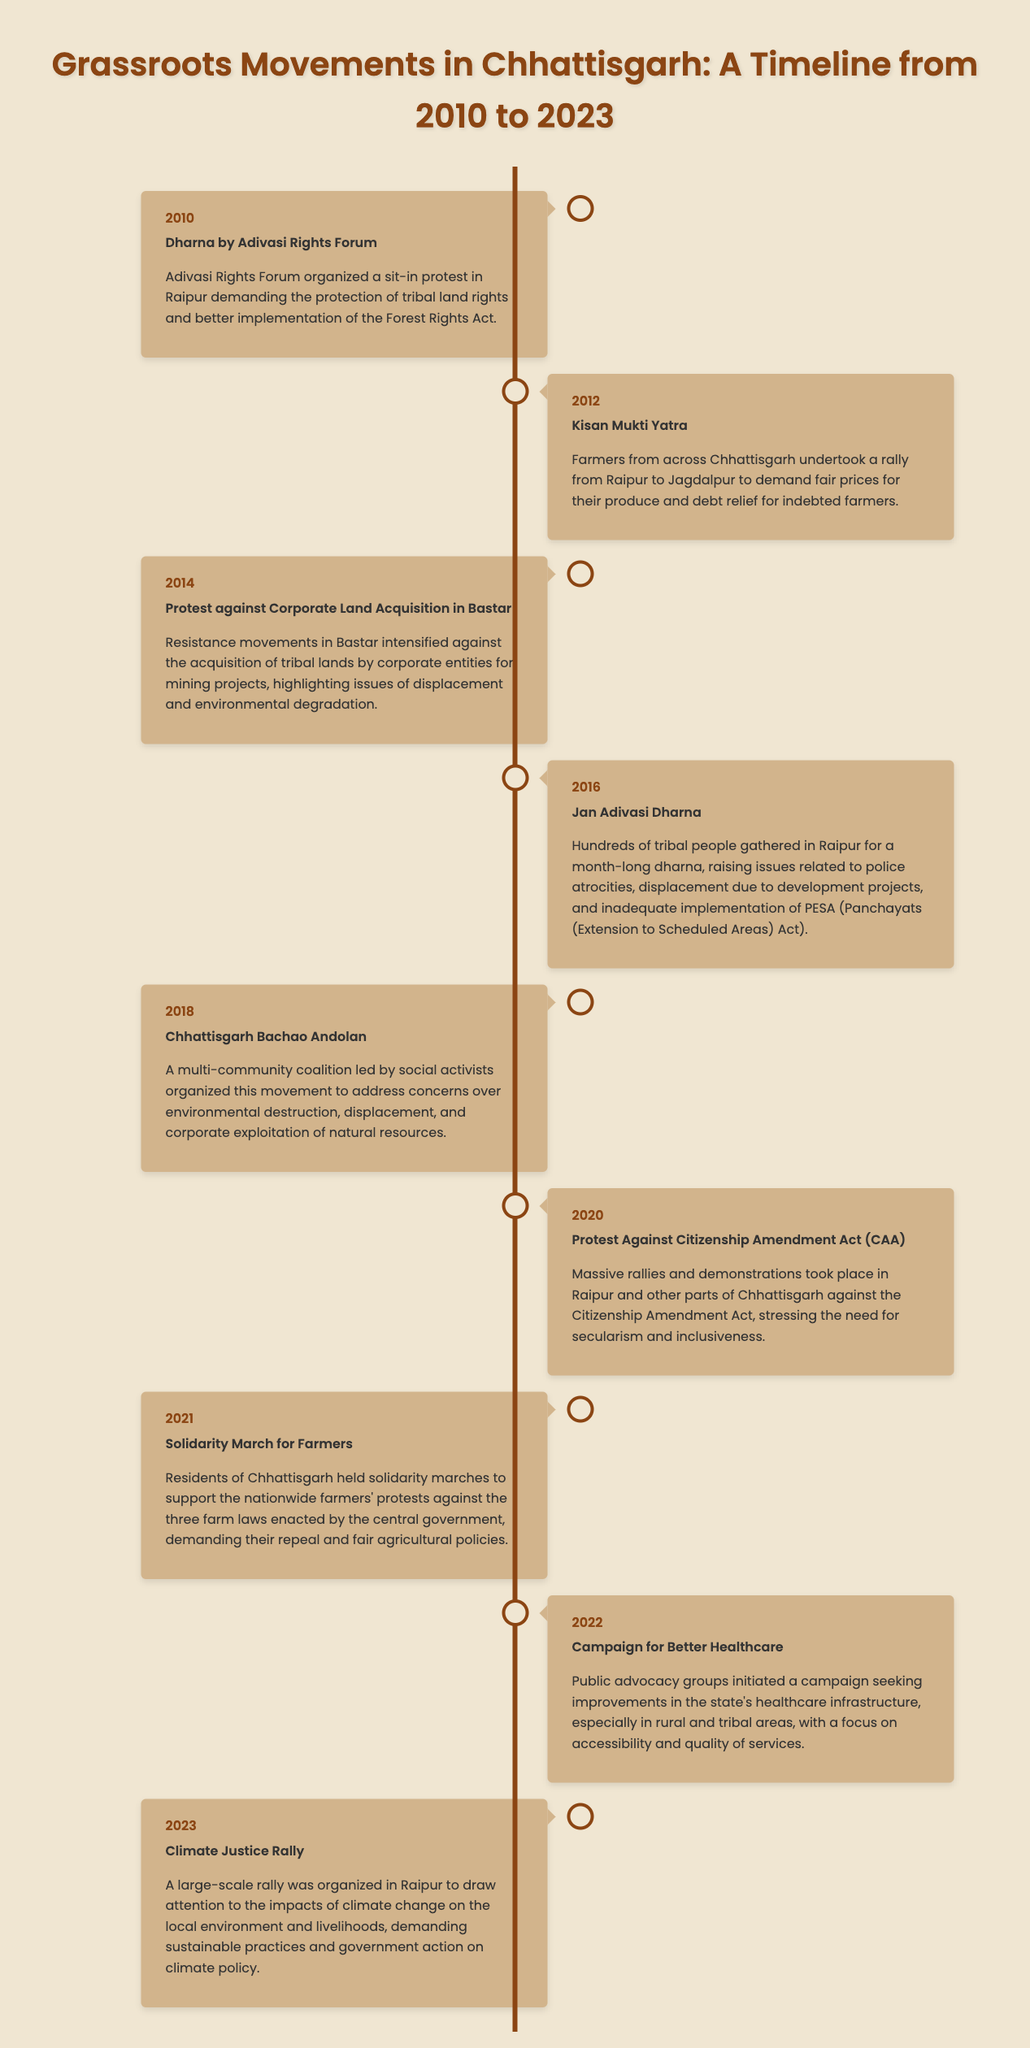What was the event in 2010? The event in 2010 is detailed in the timeline as "Dharna by Adivasi Rights Forum."
Answer: Dharna by Adivasi Rights Forum What year did the Kisan Mukti Yatra take place? The Kisan Mukti Yatra occurred in 2012, as indicated in the timeline.
Answer: 2012 Which protest focused on climate justice? The climate justice rally, stated in the timeline, focuses on climate change impacts and occurred in 2023.
Answer: Climate Justice Rally What were the main issues raised during the Jan Adivasi Dharna in 2016? The Jan Adivasi Dharna raised issues of police atrocities, displacement, and inadequate implementation of PESA.
Answer: Police atrocities, displacement, inadequate implementation of PESA How many years did the timeline cover? The timeline spans from 2010 to 2023, covering a total of 14 years.
Answer: 14 years What was the focus of the 2022 campaign? The campaign in 2022 sought improvements in the state's healthcare infrastructure, particularly in rural and tribal areas.
Answer: Better Healthcare What was the purpose of the Solidarity March for Farmers in 2021? The Solidarity March aimed to support the nationwide farmers' protests against three farm laws.
Answer: Support for farmers' protests Who led the Chhattisgarh Bachao Andolan in 2018? The Chhattisgarh Bachao Andolan was led by social activists, according to the timeline.
Answer: Social activists What type of movements are detailed in the document? The document highlights grassroots movements, specifically protests, rallies, and public advocacy campaigns.
Answer: Grassroots movements 